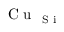Convert formula to latex. <formula><loc_0><loc_0><loc_500><loc_500>C u _ { S i }</formula> 